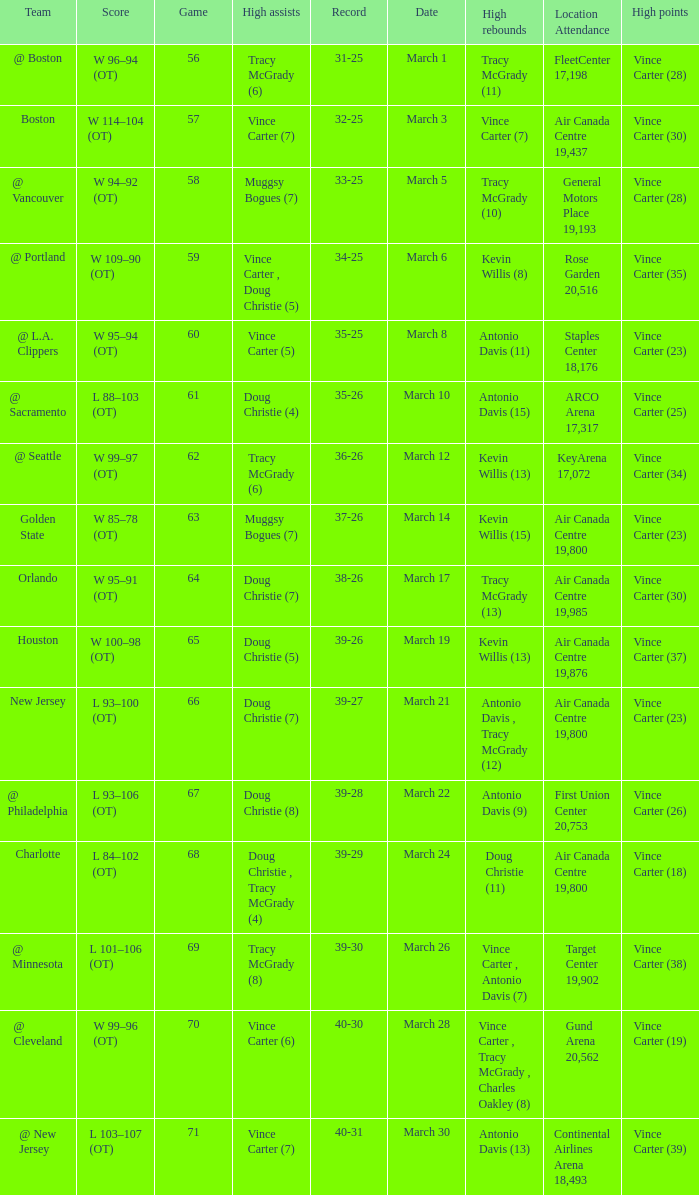Where did the team play and what was the attendance against new jersey? Air Canada Centre 19,800. 